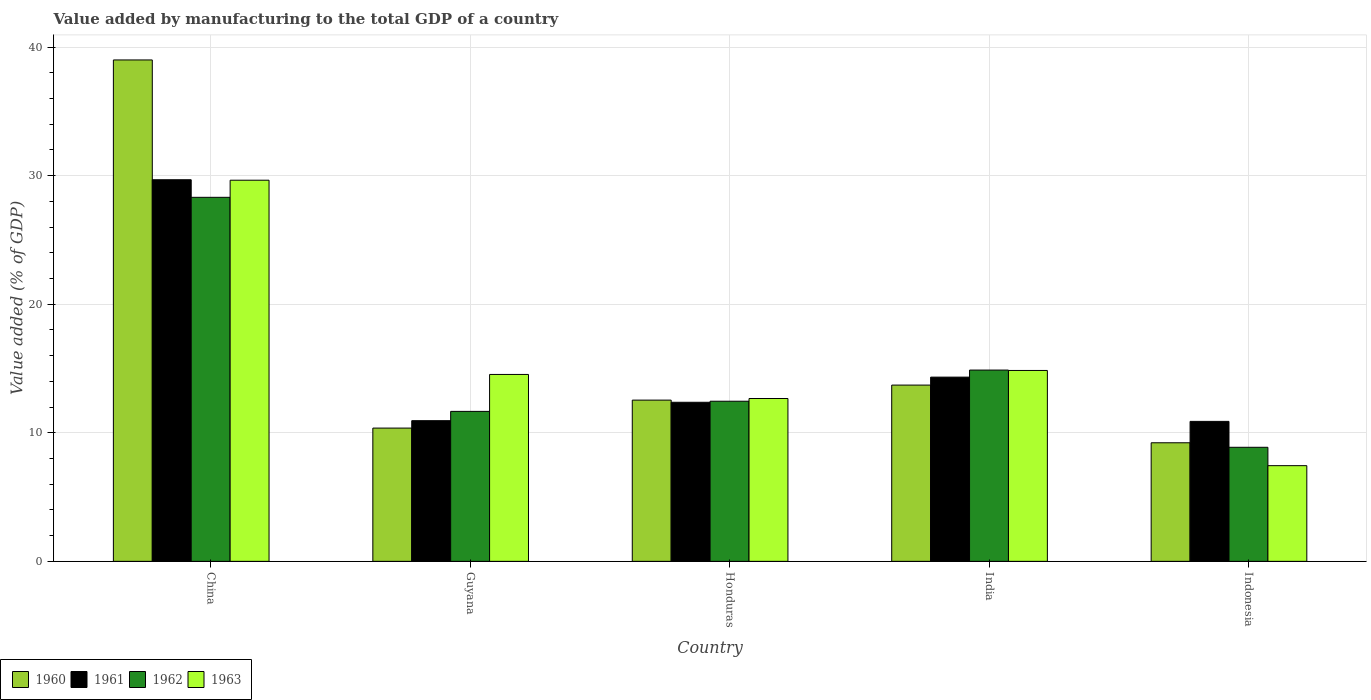How many bars are there on the 3rd tick from the right?
Offer a terse response. 4. What is the value added by manufacturing to the total GDP in 1963 in Honduras?
Your response must be concise. 12.67. Across all countries, what is the maximum value added by manufacturing to the total GDP in 1960?
Offer a terse response. 39. Across all countries, what is the minimum value added by manufacturing to the total GDP in 1961?
Your answer should be very brief. 10.89. In which country was the value added by manufacturing to the total GDP in 1962 maximum?
Give a very brief answer. China. What is the total value added by manufacturing to the total GDP in 1961 in the graph?
Provide a short and direct response. 78.21. What is the difference between the value added by manufacturing to the total GDP in 1960 in China and that in India?
Give a very brief answer. 25.29. What is the difference between the value added by manufacturing to the total GDP in 1962 in Guyana and the value added by manufacturing to the total GDP in 1961 in Indonesia?
Give a very brief answer. 0.78. What is the average value added by manufacturing to the total GDP in 1961 per country?
Your response must be concise. 15.64. What is the difference between the value added by manufacturing to the total GDP of/in 1963 and value added by manufacturing to the total GDP of/in 1962 in China?
Give a very brief answer. 1.33. What is the ratio of the value added by manufacturing to the total GDP in 1961 in Guyana to that in Indonesia?
Offer a very short reply. 1. Is the value added by manufacturing to the total GDP in 1962 in Guyana less than that in India?
Keep it short and to the point. Yes. Is the difference between the value added by manufacturing to the total GDP in 1963 in Honduras and Indonesia greater than the difference between the value added by manufacturing to the total GDP in 1962 in Honduras and Indonesia?
Your answer should be compact. Yes. What is the difference between the highest and the second highest value added by manufacturing to the total GDP in 1960?
Your answer should be very brief. -1.17. What is the difference between the highest and the lowest value added by manufacturing to the total GDP in 1960?
Your response must be concise. 29.77. In how many countries, is the value added by manufacturing to the total GDP in 1961 greater than the average value added by manufacturing to the total GDP in 1961 taken over all countries?
Offer a very short reply. 1. Is it the case that in every country, the sum of the value added by manufacturing to the total GDP in 1960 and value added by manufacturing to the total GDP in 1963 is greater than the sum of value added by manufacturing to the total GDP in 1962 and value added by manufacturing to the total GDP in 1961?
Offer a very short reply. No. What does the 2nd bar from the right in Indonesia represents?
Keep it short and to the point. 1962. How many bars are there?
Offer a terse response. 20. How many countries are there in the graph?
Your response must be concise. 5. Are the values on the major ticks of Y-axis written in scientific E-notation?
Your answer should be compact. No. Does the graph contain any zero values?
Ensure brevity in your answer.  No. Does the graph contain grids?
Ensure brevity in your answer.  Yes. How many legend labels are there?
Provide a succinct answer. 4. How are the legend labels stacked?
Provide a short and direct response. Horizontal. What is the title of the graph?
Ensure brevity in your answer.  Value added by manufacturing to the total GDP of a country. What is the label or title of the Y-axis?
Offer a very short reply. Value added (% of GDP). What is the Value added (% of GDP) of 1960 in China?
Provide a short and direct response. 39. What is the Value added (% of GDP) of 1961 in China?
Your answer should be very brief. 29.68. What is the Value added (% of GDP) in 1962 in China?
Provide a succinct answer. 28.31. What is the Value added (% of GDP) in 1963 in China?
Offer a very short reply. 29.64. What is the Value added (% of GDP) of 1960 in Guyana?
Your response must be concise. 10.37. What is the Value added (% of GDP) in 1961 in Guyana?
Your answer should be compact. 10.94. What is the Value added (% of GDP) in 1962 in Guyana?
Ensure brevity in your answer.  11.66. What is the Value added (% of GDP) in 1963 in Guyana?
Provide a short and direct response. 14.54. What is the Value added (% of GDP) of 1960 in Honduras?
Provide a succinct answer. 12.54. What is the Value added (% of GDP) of 1961 in Honduras?
Offer a very short reply. 12.37. What is the Value added (% of GDP) in 1962 in Honduras?
Make the answer very short. 12.45. What is the Value added (% of GDP) of 1963 in Honduras?
Offer a very short reply. 12.67. What is the Value added (% of GDP) in 1960 in India?
Make the answer very short. 13.71. What is the Value added (% of GDP) of 1961 in India?
Provide a short and direct response. 14.33. What is the Value added (% of GDP) of 1962 in India?
Keep it short and to the point. 14.88. What is the Value added (% of GDP) in 1963 in India?
Your answer should be very brief. 14.85. What is the Value added (% of GDP) in 1960 in Indonesia?
Offer a terse response. 9.22. What is the Value added (% of GDP) in 1961 in Indonesia?
Provide a succinct answer. 10.89. What is the Value added (% of GDP) in 1962 in Indonesia?
Make the answer very short. 8.87. What is the Value added (% of GDP) of 1963 in Indonesia?
Keep it short and to the point. 7.44. Across all countries, what is the maximum Value added (% of GDP) of 1960?
Your response must be concise. 39. Across all countries, what is the maximum Value added (% of GDP) of 1961?
Offer a very short reply. 29.68. Across all countries, what is the maximum Value added (% of GDP) of 1962?
Provide a succinct answer. 28.31. Across all countries, what is the maximum Value added (% of GDP) of 1963?
Provide a succinct answer. 29.64. Across all countries, what is the minimum Value added (% of GDP) in 1960?
Offer a very short reply. 9.22. Across all countries, what is the minimum Value added (% of GDP) of 1961?
Provide a short and direct response. 10.89. Across all countries, what is the minimum Value added (% of GDP) in 1962?
Your response must be concise. 8.87. Across all countries, what is the minimum Value added (% of GDP) of 1963?
Provide a succinct answer. 7.44. What is the total Value added (% of GDP) of 1960 in the graph?
Your response must be concise. 84.84. What is the total Value added (% of GDP) of 1961 in the graph?
Give a very brief answer. 78.21. What is the total Value added (% of GDP) of 1962 in the graph?
Your answer should be very brief. 76.18. What is the total Value added (% of GDP) of 1963 in the graph?
Ensure brevity in your answer.  79.14. What is the difference between the Value added (% of GDP) of 1960 in China and that in Guyana?
Provide a short and direct response. 28.63. What is the difference between the Value added (% of GDP) in 1961 in China and that in Guyana?
Ensure brevity in your answer.  18.74. What is the difference between the Value added (% of GDP) of 1962 in China and that in Guyana?
Your response must be concise. 16.65. What is the difference between the Value added (% of GDP) of 1963 in China and that in Guyana?
Ensure brevity in your answer.  15.11. What is the difference between the Value added (% of GDP) in 1960 in China and that in Honduras?
Your answer should be compact. 26.46. What is the difference between the Value added (% of GDP) in 1961 in China and that in Honduras?
Keep it short and to the point. 17.31. What is the difference between the Value added (% of GDP) in 1962 in China and that in Honduras?
Make the answer very short. 15.86. What is the difference between the Value added (% of GDP) in 1963 in China and that in Honduras?
Your answer should be compact. 16.98. What is the difference between the Value added (% of GDP) in 1960 in China and that in India?
Keep it short and to the point. 25.29. What is the difference between the Value added (% of GDP) in 1961 in China and that in India?
Your answer should be compact. 15.35. What is the difference between the Value added (% of GDP) in 1962 in China and that in India?
Make the answer very short. 13.43. What is the difference between the Value added (% of GDP) of 1963 in China and that in India?
Offer a terse response. 14.8. What is the difference between the Value added (% of GDP) in 1960 in China and that in Indonesia?
Give a very brief answer. 29.77. What is the difference between the Value added (% of GDP) of 1961 in China and that in Indonesia?
Make the answer very short. 18.79. What is the difference between the Value added (% of GDP) in 1962 in China and that in Indonesia?
Keep it short and to the point. 19.44. What is the difference between the Value added (% of GDP) of 1963 in China and that in Indonesia?
Your response must be concise. 22.2. What is the difference between the Value added (% of GDP) in 1960 in Guyana and that in Honduras?
Your response must be concise. -2.18. What is the difference between the Value added (% of GDP) in 1961 in Guyana and that in Honduras?
Your answer should be compact. -1.43. What is the difference between the Value added (% of GDP) of 1962 in Guyana and that in Honduras?
Your answer should be very brief. -0.79. What is the difference between the Value added (% of GDP) in 1963 in Guyana and that in Honduras?
Keep it short and to the point. 1.87. What is the difference between the Value added (% of GDP) in 1960 in Guyana and that in India?
Give a very brief answer. -3.34. What is the difference between the Value added (% of GDP) in 1961 in Guyana and that in India?
Offer a terse response. -3.39. What is the difference between the Value added (% of GDP) in 1962 in Guyana and that in India?
Your answer should be compact. -3.21. What is the difference between the Value added (% of GDP) in 1963 in Guyana and that in India?
Offer a very short reply. -0.31. What is the difference between the Value added (% of GDP) in 1960 in Guyana and that in Indonesia?
Ensure brevity in your answer.  1.14. What is the difference between the Value added (% of GDP) of 1961 in Guyana and that in Indonesia?
Provide a succinct answer. 0.05. What is the difference between the Value added (% of GDP) in 1962 in Guyana and that in Indonesia?
Provide a succinct answer. 2.79. What is the difference between the Value added (% of GDP) in 1963 in Guyana and that in Indonesia?
Your answer should be compact. 7.09. What is the difference between the Value added (% of GDP) of 1960 in Honduras and that in India?
Offer a terse response. -1.17. What is the difference between the Value added (% of GDP) in 1961 in Honduras and that in India?
Make the answer very short. -1.96. What is the difference between the Value added (% of GDP) in 1962 in Honduras and that in India?
Give a very brief answer. -2.42. What is the difference between the Value added (% of GDP) of 1963 in Honduras and that in India?
Offer a very short reply. -2.18. What is the difference between the Value added (% of GDP) in 1960 in Honduras and that in Indonesia?
Your answer should be very brief. 3.32. What is the difference between the Value added (% of GDP) of 1961 in Honduras and that in Indonesia?
Give a very brief answer. 1.49. What is the difference between the Value added (% of GDP) in 1962 in Honduras and that in Indonesia?
Offer a very short reply. 3.58. What is the difference between the Value added (% of GDP) of 1963 in Honduras and that in Indonesia?
Keep it short and to the point. 5.22. What is the difference between the Value added (% of GDP) in 1960 in India and that in Indonesia?
Provide a short and direct response. 4.49. What is the difference between the Value added (% of GDP) in 1961 in India and that in Indonesia?
Your answer should be compact. 3.44. What is the difference between the Value added (% of GDP) of 1962 in India and that in Indonesia?
Ensure brevity in your answer.  6.01. What is the difference between the Value added (% of GDP) of 1963 in India and that in Indonesia?
Your answer should be very brief. 7.4. What is the difference between the Value added (% of GDP) in 1960 in China and the Value added (% of GDP) in 1961 in Guyana?
Ensure brevity in your answer.  28.06. What is the difference between the Value added (% of GDP) in 1960 in China and the Value added (% of GDP) in 1962 in Guyana?
Provide a succinct answer. 27.33. What is the difference between the Value added (% of GDP) in 1960 in China and the Value added (% of GDP) in 1963 in Guyana?
Make the answer very short. 24.46. What is the difference between the Value added (% of GDP) of 1961 in China and the Value added (% of GDP) of 1962 in Guyana?
Provide a short and direct response. 18.02. What is the difference between the Value added (% of GDP) in 1961 in China and the Value added (% of GDP) in 1963 in Guyana?
Ensure brevity in your answer.  15.14. What is the difference between the Value added (% of GDP) in 1962 in China and the Value added (% of GDP) in 1963 in Guyana?
Make the answer very short. 13.78. What is the difference between the Value added (% of GDP) of 1960 in China and the Value added (% of GDP) of 1961 in Honduras?
Offer a very short reply. 26.63. What is the difference between the Value added (% of GDP) in 1960 in China and the Value added (% of GDP) in 1962 in Honduras?
Your answer should be compact. 26.54. What is the difference between the Value added (% of GDP) of 1960 in China and the Value added (% of GDP) of 1963 in Honduras?
Your answer should be compact. 26.33. What is the difference between the Value added (% of GDP) in 1961 in China and the Value added (% of GDP) in 1962 in Honduras?
Offer a very short reply. 17.23. What is the difference between the Value added (% of GDP) of 1961 in China and the Value added (% of GDP) of 1963 in Honduras?
Ensure brevity in your answer.  17.01. What is the difference between the Value added (% of GDP) in 1962 in China and the Value added (% of GDP) in 1963 in Honduras?
Provide a short and direct response. 15.65. What is the difference between the Value added (% of GDP) of 1960 in China and the Value added (% of GDP) of 1961 in India?
Keep it short and to the point. 24.67. What is the difference between the Value added (% of GDP) of 1960 in China and the Value added (% of GDP) of 1962 in India?
Give a very brief answer. 24.12. What is the difference between the Value added (% of GDP) in 1960 in China and the Value added (% of GDP) in 1963 in India?
Offer a very short reply. 24.15. What is the difference between the Value added (% of GDP) in 1961 in China and the Value added (% of GDP) in 1962 in India?
Your answer should be very brief. 14.8. What is the difference between the Value added (% of GDP) in 1961 in China and the Value added (% of GDP) in 1963 in India?
Offer a very short reply. 14.83. What is the difference between the Value added (% of GDP) of 1962 in China and the Value added (% of GDP) of 1963 in India?
Ensure brevity in your answer.  13.47. What is the difference between the Value added (% of GDP) in 1960 in China and the Value added (% of GDP) in 1961 in Indonesia?
Ensure brevity in your answer.  28.11. What is the difference between the Value added (% of GDP) of 1960 in China and the Value added (% of GDP) of 1962 in Indonesia?
Offer a very short reply. 30.13. What is the difference between the Value added (% of GDP) of 1960 in China and the Value added (% of GDP) of 1963 in Indonesia?
Keep it short and to the point. 31.56. What is the difference between the Value added (% of GDP) of 1961 in China and the Value added (% of GDP) of 1962 in Indonesia?
Offer a very short reply. 20.81. What is the difference between the Value added (% of GDP) in 1961 in China and the Value added (% of GDP) in 1963 in Indonesia?
Provide a succinct answer. 22.24. What is the difference between the Value added (% of GDP) in 1962 in China and the Value added (% of GDP) in 1963 in Indonesia?
Your response must be concise. 20.87. What is the difference between the Value added (% of GDP) in 1960 in Guyana and the Value added (% of GDP) in 1961 in Honduras?
Provide a succinct answer. -2.01. What is the difference between the Value added (% of GDP) of 1960 in Guyana and the Value added (% of GDP) of 1962 in Honduras?
Your answer should be compact. -2.09. What is the difference between the Value added (% of GDP) in 1960 in Guyana and the Value added (% of GDP) in 1963 in Honduras?
Provide a short and direct response. -2.3. What is the difference between the Value added (% of GDP) in 1961 in Guyana and the Value added (% of GDP) in 1962 in Honduras?
Keep it short and to the point. -1.51. What is the difference between the Value added (% of GDP) of 1961 in Guyana and the Value added (% of GDP) of 1963 in Honduras?
Your response must be concise. -1.73. What is the difference between the Value added (% of GDP) of 1962 in Guyana and the Value added (% of GDP) of 1963 in Honduras?
Provide a short and direct response. -1. What is the difference between the Value added (% of GDP) of 1960 in Guyana and the Value added (% of GDP) of 1961 in India?
Offer a terse response. -3.96. What is the difference between the Value added (% of GDP) in 1960 in Guyana and the Value added (% of GDP) in 1962 in India?
Ensure brevity in your answer.  -4.51. What is the difference between the Value added (% of GDP) of 1960 in Guyana and the Value added (% of GDP) of 1963 in India?
Give a very brief answer. -4.48. What is the difference between the Value added (% of GDP) of 1961 in Guyana and the Value added (% of GDP) of 1962 in India?
Offer a very short reply. -3.94. What is the difference between the Value added (% of GDP) of 1961 in Guyana and the Value added (% of GDP) of 1963 in India?
Provide a succinct answer. -3.91. What is the difference between the Value added (% of GDP) in 1962 in Guyana and the Value added (% of GDP) in 1963 in India?
Your answer should be very brief. -3.18. What is the difference between the Value added (% of GDP) in 1960 in Guyana and the Value added (% of GDP) in 1961 in Indonesia?
Make the answer very short. -0.52. What is the difference between the Value added (% of GDP) of 1960 in Guyana and the Value added (% of GDP) of 1962 in Indonesia?
Provide a short and direct response. 1.49. What is the difference between the Value added (% of GDP) in 1960 in Guyana and the Value added (% of GDP) in 1963 in Indonesia?
Provide a short and direct response. 2.92. What is the difference between the Value added (% of GDP) of 1961 in Guyana and the Value added (% of GDP) of 1962 in Indonesia?
Your answer should be compact. 2.07. What is the difference between the Value added (% of GDP) in 1961 in Guyana and the Value added (% of GDP) in 1963 in Indonesia?
Provide a short and direct response. 3.5. What is the difference between the Value added (% of GDP) of 1962 in Guyana and the Value added (% of GDP) of 1963 in Indonesia?
Your response must be concise. 4.22. What is the difference between the Value added (% of GDP) of 1960 in Honduras and the Value added (% of GDP) of 1961 in India?
Ensure brevity in your answer.  -1.79. What is the difference between the Value added (% of GDP) of 1960 in Honduras and the Value added (% of GDP) of 1962 in India?
Your answer should be compact. -2.34. What is the difference between the Value added (% of GDP) in 1960 in Honduras and the Value added (% of GDP) in 1963 in India?
Your answer should be compact. -2.31. What is the difference between the Value added (% of GDP) of 1961 in Honduras and the Value added (% of GDP) of 1962 in India?
Give a very brief answer. -2.51. What is the difference between the Value added (% of GDP) of 1961 in Honduras and the Value added (% of GDP) of 1963 in India?
Your response must be concise. -2.47. What is the difference between the Value added (% of GDP) of 1962 in Honduras and the Value added (% of GDP) of 1963 in India?
Provide a short and direct response. -2.39. What is the difference between the Value added (% of GDP) of 1960 in Honduras and the Value added (% of GDP) of 1961 in Indonesia?
Make the answer very short. 1.65. What is the difference between the Value added (% of GDP) in 1960 in Honduras and the Value added (% of GDP) in 1962 in Indonesia?
Your answer should be very brief. 3.67. What is the difference between the Value added (% of GDP) of 1960 in Honduras and the Value added (% of GDP) of 1963 in Indonesia?
Keep it short and to the point. 5.1. What is the difference between the Value added (% of GDP) of 1961 in Honduras and the Value added (% of GDP) of 1962 in Indonesia?
Your answer should be compact. 3.5. What is the difference between the Value added (% of GDP) in 1961 in Honduras and the Value added (% of GDP) in 1963 in Indonesia?
Give a very brief answer. 4.93. What is the difference between the Value added (% of GDP) of 1962 in Honduras and the Value added (% of GDP) of 1963 in Indonesia?
Make the answer very short. 5.01. What is the difference between the Value added (% of GDP) in 1960 in India and the Value added (% of GDP) in 1961 in Indonesia?
Give a very brief answer. 2.82. What is the difference between the Value added (% of GDP) in 1960 in India and the Value added (% of GDP) in 1962 in Indonesia?
Provide a succinct answer. 4.84. What is the difference between the Value added (% of GDP) of 1960 in India and the Value added (% of GDP) of 1963 in Indonesia?
Provide a short and direct response. 6.27. What is the difference between the Value added (% of GDP) of 1961 in India and the Value added (% of GDP) of 1962 in Indonesia?
Offer a very short reply. 5.46. What is the difference between the Value added (% of GDP) in 1961 in India and the Value added (% of GDP) in 1963 in Indonesia?
Keep it short and to the point. 6.89. What is the difference between the Value added (% of GDP) of 1962 in India and the Value added (% of GDP) of 1963 in Indonesia?
Your response must be concise. 7.44. What is the average Value added (% of GDP) of 1960 per country?
Your answer should be very brief. 16.97. What is the average Value added (% of GDP) of 1961 per country?
Make the answer very short. 15.64. What is the average Value added (% of GDP) of 1962 per country?
Provide a short and direct response. 15.24. What is the average Value added (% of GDP) of 1963 per country?
Give a very brief answer. 15.83. What is the difference between the Value added (% of GDP) of 1960 and Value added (% of GDP) of 1961 in China?
Make the answer very short. 9.32. What is the difference between the Value added (% of GDP) in 1960 and Value added (% of GDP) in 1962 in China?
Ensure brevity in your answer.  10.69. What is the difference between the Value added (% of GDP) of 1960 and Value added (% of GDP) of 1963 in China?
Offer a terse response. 9.35. What is the difference between the Value added (% of GDP) in 1961 and Value added (% of GDP) in 1962 in China?
Your answer should be compact. 1.37. What is the difference between the Value added (% of GDP) in 1961 and Value added (% of GDP) in 1963 in China?
Your response must be concise. 0.04. What is the difference between the Value added (% of GDP) of 1962 and Value added (% of GDP) of 1963 in China?
Ensure brevity in your answer.  -1.33. What is the difference between the Value added (% of GDP) of 1960 and Value added (% of GDP) of 1961 in Guyana?
Make the answer very short. -0.58. What is the difference between the Value added (% of GDP) of 1960 and Value added (% of GDP) of 1962 in Guyana?
Offer a very short reply. -1.3. What is the difference between the Value added (% of GDP) of 1960 and Value added (% of GDP) of 1963 in Guyana?
Your answer should be very brief. -4.17. What is the difference between the Value added (% of GDP) of 1961 and Value added (% of GDP) of 1962 in Guyana?
Keep it short and to the point. -0.72. What is the difference between the Value added (% of GDP) in 1961 and Value added (% of GDP) in 1963 in Guyana?
Provide a succinct answer. -3.6. What is the difference between the Value added (% of GDP) in 1962 and Value added (% of GDP) in 1963 in Guyana?
Give a very brief answer. -2.87. What is the difference between the Value added (% of GDP) in 1960 and Value added (% of GDP) in 1961 in Honduras?
Your response must be concise. 0.17. What is the difference between the Value added (% of GDP) of 1960 and Value added (% of GDP) of 1962 in Honduras?
Keep it short and to the point. 0.09. What is the difference between the Value added (% of GDP) of 1960 and Value added (% of GDP) of 1963 in Honduras?
Your response must be concise. -0.13. What is the difference between the Value added (% of GDP) of 1961 and Value added (% of GDP) of 1962 in Honduras?
Provide a succinct answer. -0.08. What is the difference between the Value added (% of GDP) of 1961 and Value added (% of GDP) of 1963 in Honduras?
Provide a succinct answer. -0.29. What is the difference between the Value added (% of GDP) in 1962 and Value added (% of GDP) in 1963 in Honduras?
Provide a succinct answer. -0.21. What is the difference between the Value added (% of GDP) of 1960 and Value added (% of GDP) of 1961 in India?
Make the answer very short. -0.62. What is the difference between the Value added (% of GDP) of 1960 and Value added (% of GDP) of 1962 in India?
Give a very brief answer. -1.17. What is the difference between the Value added (% of GDP) of 1960 and Value added (% of GDP) of 1963 in India?
Your answer should be compact. -1.14. What is the difference between the Value added (% of GDP) in 1961 and Value added (% of GDP) in 1962 in India?
Your response must be concise. -0.55. What is the difference between the Value added (% of GDP) of 1961 and Value added (% of GDP) of 1963 in India?
Your response must be concise. -0.52. What is the difference between the Value added (% of GDP) of 1962 and Value added (% of GDP) of 1963 in India?
Provide a short and direct response. 0.03. What is the difference between the Value added (% of GDP) of 1960 and Value added (% of GDP) of 1961 in Indonesia?
Keep it short and to the point. -1.66. What is the difference between the Value added (% of GDP) in 1960 and Value added (% of GDP) in 1962 in Indonesia?
Your response must be concise. 0.35. What is the difference between the Value added (% of GDP) in 1960 and Value added (% of GDP) in 1963 in Indonesia?
Your answer should be very brief. 1.78. What is the difference between the Value added (% of GDP) in 1961 and Value added (% of GDP) in 1962 in Indonesia?
Your response must be concise. 2.02. What is the difference between the Value added (% of GDP) of 1961 and Value added (% of GDP) of 1963 in Indonesia?
Your response must be concise. 3.44. What is the difference between the Value added (% of GDP) of 1962 and Value added (% of GDP) of 1963 in Indonesia?
Make the answer very short. 1.43. What is the ratio of the Value added (% of GDP) of 1960 in China to that in Guyana?
Your answer should be very brief. 3.76. What is the ratio of the Value added (% of GDP) in 1961 in China to that in Guyana?
Provide a succinct answer. 2.71. What is the ratio of the Value added (% of GDP) in 1962 in China to that in Guyana?
Offer a terse response. 2.43. What is the ratio of the Value added (% of GDP) of 1963 in China to that in Guyana?
Provide a succinct answer. 2.04. What is the ratio of the Value added (% of GDP) in 1960 in China to that in Honduras?
Offer a terse response. 3.11. What is the ratio of the Value added (% of GDP) in 1961 in China to that in Honduras?
Your answer should be very brief. 2.4. What is the ratio of the Value added (% of GDP) of 1962 in China to that in Honduras?
Make the answer very short. 2.27. What is the ratio of the Value added (% of GDP) of 1963 in China to that in Honduras?
Your answer should be very brief. 2.34. What is the ratio of the Value added (% of GDP) in 1960 in China to that in India?
Your answer should be very brief. 2.84. What is the ratio of the Value added (% of GDP) of 1961 in China to that in India?
Offer a very short reply. 2.07. What is the ratio of the Value added (% of GDP) in 1962 in China to that in India?
Your answer should be compact. 1.9. What is the ratio of the Value added (% of GDP) in 1963 in China to that in India?
Keep it short and to the point. 2. What is the ratio of the Value added (% of GDP) of 1960 in China to that in Indonesia?
Offer a terse response. 4.23. What is the ratio of the Value added (% of GDP) of 1961 in China to that in Indonesia?
Provide a succinct answer. 2.73. What is the ratio of the Value added (% of GDP) in 1962 in China to that in Indonesia?
Give a very brief answer. 3.19. What is the ratio of the Value added (% of GDP) of 1963 in China to that in Indonesia?
Ensure brevity in your answer.  3.98. What is the ratio of the Value added (% of GDP) of 1960 in Guyana to that in Honduras?
Your answer should be very brief. 0.83. What is the ratio of the Value added (% of GDP) of 1961 in Guyana to that in Honduras?
Provide a short and direct response. 0.88. What is the ratio of the Value added (% of GDP) of 1962 in Guyana to that in Honduras?
Provide a succinct answer. 0.94. What is the ratio of the Value added (% of GDP) in 1963 in Guyana to that in Honduras?
Your answer should be compact. 1.15. What is the ratio of the Value added (% of GDP) of 1960 in Guyana to that in India?
Keep it short and to the point. 0.76. What is the ratio of the Value added (% of GDP) of 1961 in Guyana to that in India?
Your answer should be very brief. 0.76. What is the ratio of the Value added (% of GDP) of 1962 in Guyana to that in India?
Your response must be concise. 0.78. What is the ratio of the Value added (% of GDP) of 1963 in Guyana to that in India?
Ensure brevity in your answer.  0.98. What is the ratio of the Value added (% of GDP) of 1960 in Guyana to that in Indonesia?
Your response must be concise. 1.12. What is the ratio of the Value added (% of GDP) of 1961 in Guyana to that in Indonesia?
Offer a terse response. 1. What is the ratio of the Value added (% of GDP) of 1962 in Guyana to that in Indonesia?
Your answer should be very brief. 1.31. What is the ratio of the Value added (% of GDP) in 1963 in Guyana to that in Indonesia?
Provide a short and direct response. 1.95. What is the ratio of the Value added (% of GDP) in 1960 in Honduras to that in India?
Ensure brevity in your answer.  0.91. What is the ratio of the Value added (% of GDP) of 1961 in Honduras to that in India?
Make the answer very short. 0.86. What is the ratio of the Value added (% of GDP) of 1962 in Honduras to that in India?
Provide a short and direct response. 0.84. What is the ratio of the Value added (% of GDP) of 1963 in Honduras to that in India?
Provide a succinct answer. 0.85. What is the ratio of the Value added (% of GDP) in 1960 in Honduras to that in Indonesia?
Your answer should be compact. 1.36. What is the ratio of the Value added (% of GDP) of 1961 in Honduras to that in Indonesia?
Make the answer very short. 1.14. What is the ratio of the Value added (% of GDP) in 1962 in Honduras to that in Indonesia?
Offer a very short reply. 1.4. What is the ratio of the Value added (% of GDP) in 1963 in Honduras to that in Indonesia?
Offer a terse response. 1.7. What is the ratio of the Value added (% of GDP) of 1960 in India to that in Indonesia?
Ensure brevity in your answer.  1.49. What is the ratio of the Value added (% of GDP) of 1961 in India to that in Indonesia?
Your answer should be very brief. 1.32. What is the ratio of the Value added (% of GDP) in 1962 in India to that in Indonesia?
Give a very brief answer. 1.68. What is the ratio of the Value added (% of GDP) in 1963 in India to that in Indonesia?
Your answer should be compact. 1.99. What is the difference between the highest and the second highest Value added (% of GDP) in 1960?
Ensure brevity in your answer.  25.29. What is the difference between the highest and the second highest Value added (% of GDP) in 1961?
Give a very brief answer. 15.35. What is the difference between the highest and the second highest Value added (% of GDP) in 1962?
Ensure brevity in your answer.  13.43. What is the difference between the highest and the second highest Value added (% of GDP) of 1963?
Provide a succinct answer. 14.8. What is the difference between the highest and the lowest Value added (% of GDP) in 1960?
Your answer should be compact. 29.77. What is the difference between the highest and the lowest Value added (% of GDP) of 1961?
Offer a terse response. 18.79. What is the difference between the highest and the lowest Value added (% of GDP) in 1962?
Your answer should be very brief. 19.44. What is the difference between the highest and the lowest Value added (% of GDP) of 1963?
Offer a terse response. 22.2. 